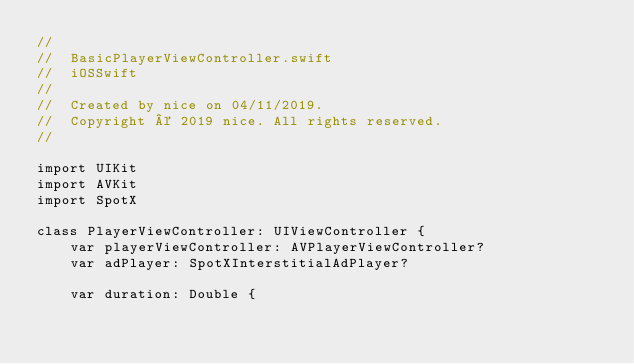Convert code to text. <code><loc_0><loc_0><loc_500><loc_500><_Swift_>//
//  BasicPlayerViewController.swift
//  iOSSwift
//
//  Created by nice on 04/11/2019.
//  Copyright © 2019 nice. All rights reserved.
//

import UIKit
import AVKit
import SpotX

class PlayerViewController: UIViewController {
    var playerViewController: AVPlayerViewController?
    var adPlayer: SpotXInterstitialAdPlayer?
    
    var duration: Double {</code> 